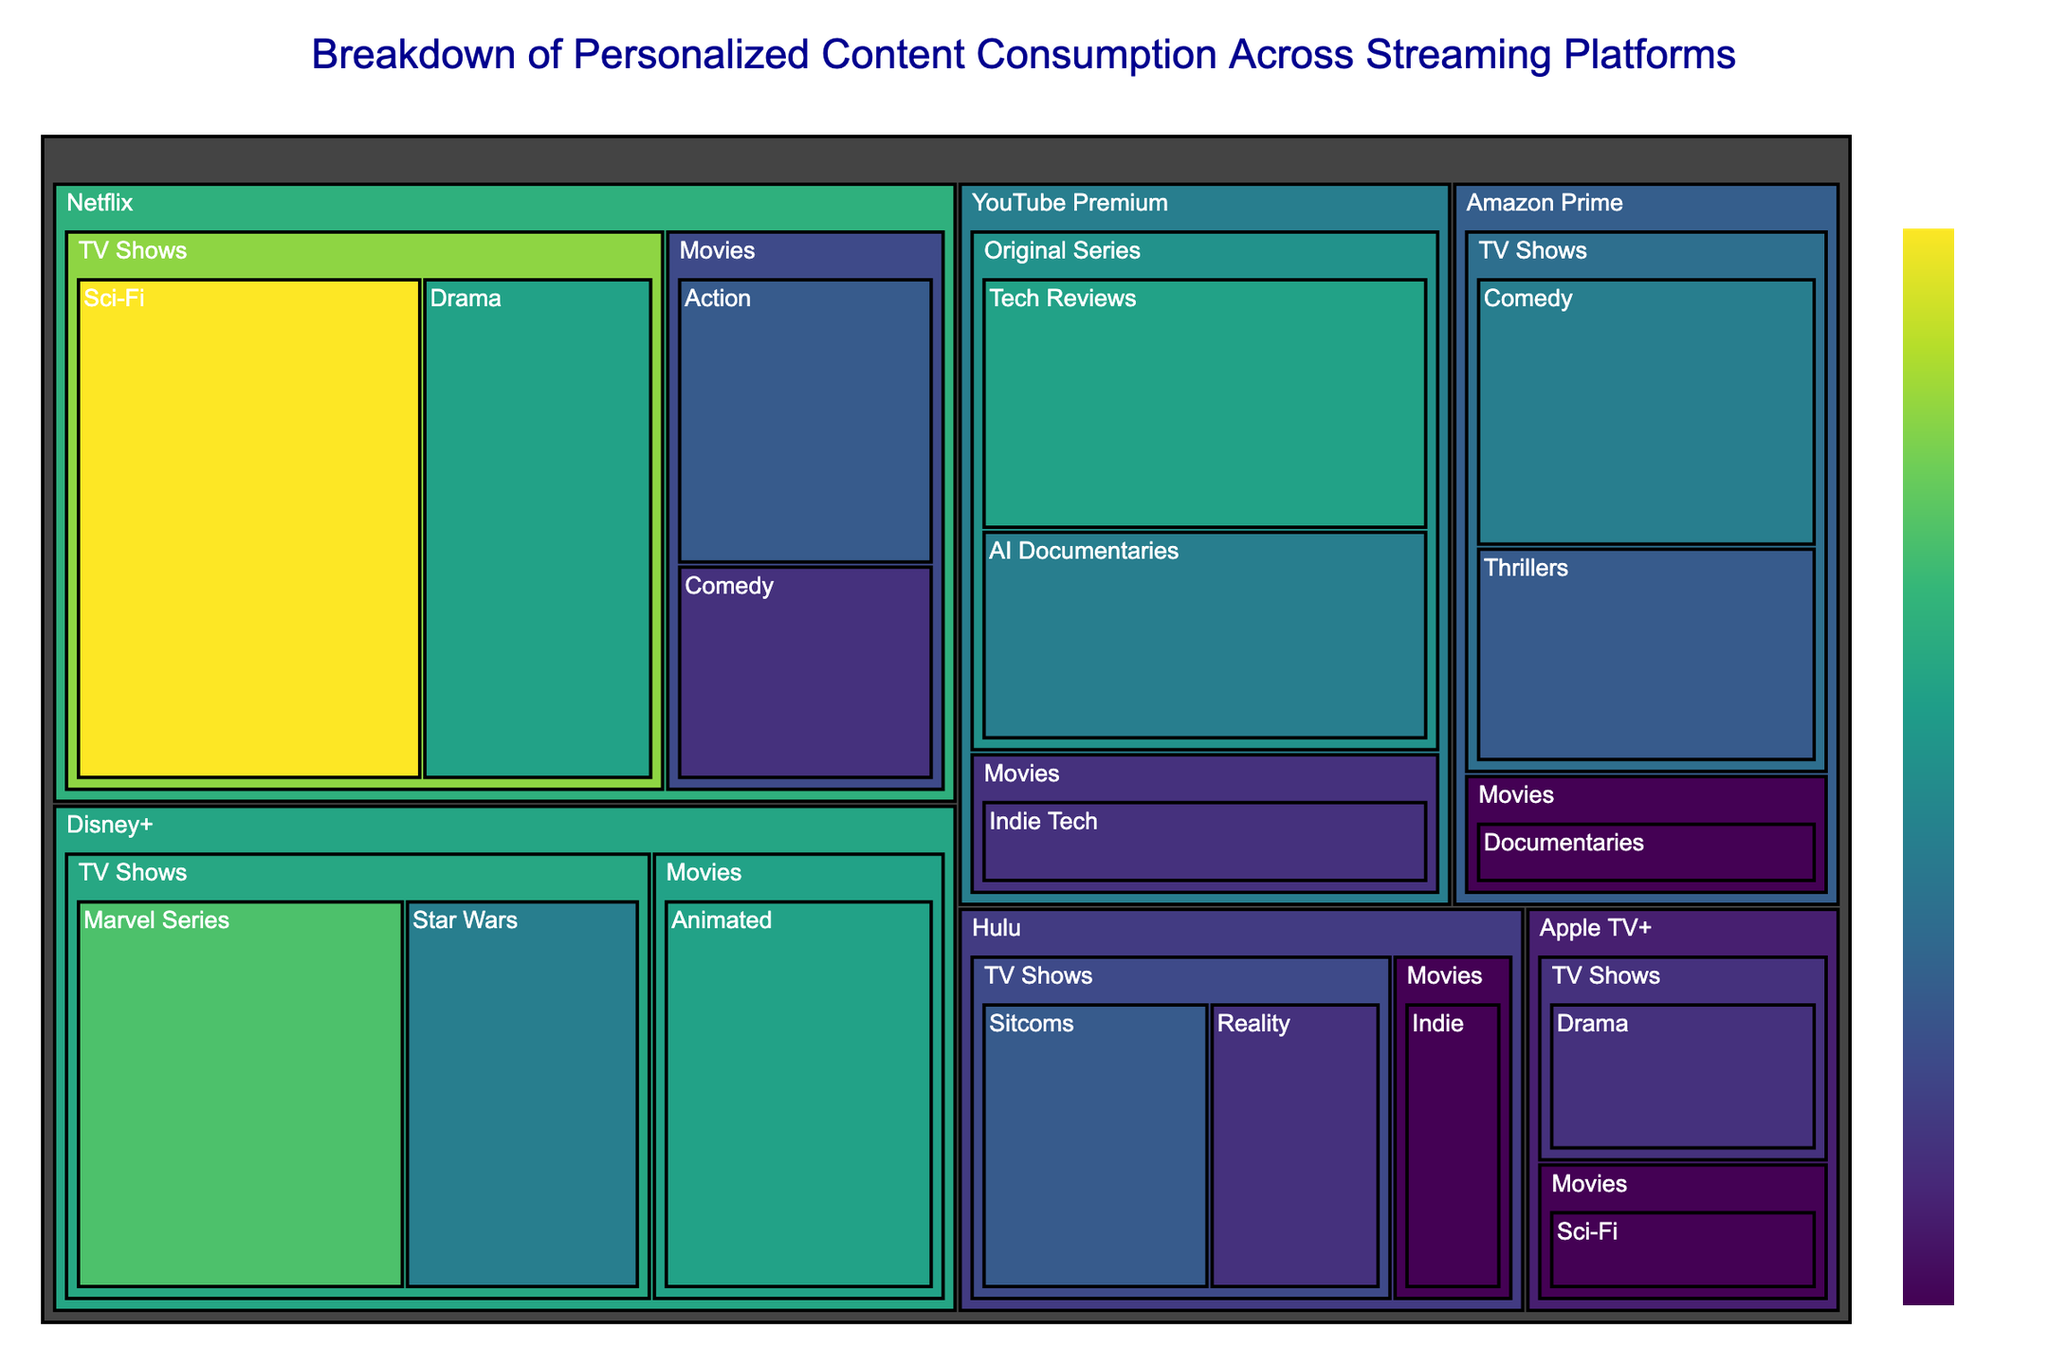Which platform has the highest total hours watched? By looking at the largest segment in the treemap, we can see which platform has the most area occupied. The platform with the highest total hours watched would have the largest combined area for all categories and subcategories.
Answer: Netflix What is the total number of hours spent watching TV Shows on Amazon Prime? To get the total hours, sum up the hours from all TV Shows subcategories under Amazon Prime. That's 25 (Comedy) + 20 (Thrillers) = 45 hours.
Answer: 45 hours Which subcategory has more hours watched, Netflix Sci-Fi TV Shows or YouTube Premium AI Documentaries? Compare the hours indicated for Netflix Sci-Fi TV Shows (45 hours) and YouTube Premium AI Documentaries (25 hours).
Answer: Netflix Sci-Fi TV Shows How many more hours are spent on Disney+ Marvel Series than on Apple TV+ Drama? Subtract the hours watched for Apple TV+ Drama (15 hours) from the hours watched for Disney+ Marvel Series (35 hours). 35 - 15 = 20 hours.
Answer: 20 hours Which category has the least number of subcategories? Look at each main category and count the number of subcategories listed. The one with the smallest count has the least number of subcategories. "Movies" on Apple TV+ and "Original Series" on YouTube Premium both have just one subcategory each.
Answer: Apple TV+ Movies and YouTube Premium Original Series What is the average number of hours spent on Disney+ categories? Add up all the hours for Disney+ subcategories and divide by the number of subcategories. That's (35 + 30 + 25) / 3 = 90 / 3 = 30 hours.
Answer: 30 hours Do Hulu Movies or Hulu TV Shows have more total hours watched? Sum up the hours for each category. Hulu Movies have 10 (Indie). Hulu TV Shows have 15 (Reality) + 20 (Sitcoms) = 35. Hulu TV Shows have more.
Answer: Hulu TV Shows Which streaming platform’s Movies category has the fewest hours watched? Compare the hours for the Movies category across all platforms: Netflix (20 + 15), Amazon Prime (10), Disney+ (30), Hulu (10), Apple TV+ (10), YouTube Premium (15). The platform is Amazon Prime.
Answer: Amazon Prime Which subcategory within Netflix has the smallest number of hours watched? Look at all the subcategories under Netflix and find the one with the smallest hours watched. That is Comedy in Movies with 15 hours.
Answer: Comedy in Movies 